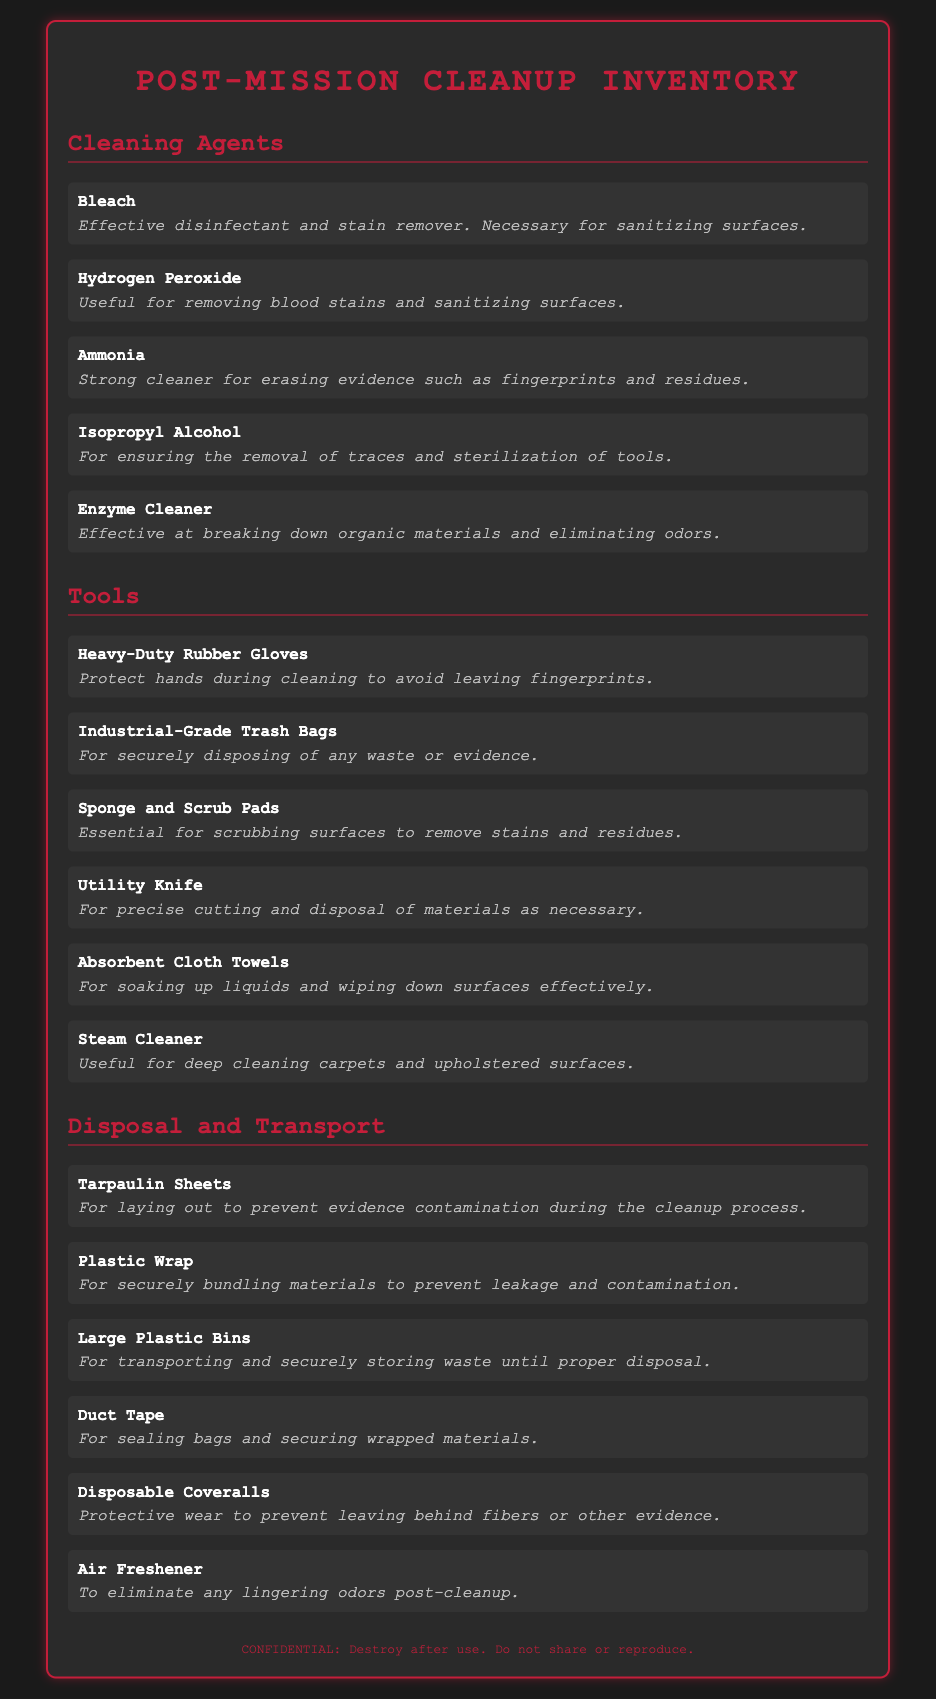What is the first cleaning agent listed? The first cleaning agent listed in the document is mentioned in the "Cleaning Agents" section.
Answer: Bleach How many cleaning agents are listed in total? The number of cleaning agents can be counted in the document under the "Cleaning Agents" category.
Answer: 5 What is the purpose of Hydrogen Peroxide? The purpose of Hydrogen Peroxide is described in the document and indicates its primary use.
Answer: Removing blood stains and sanitizing surfaces What type of gloves are mentioned for cleanup? The type of gloves used during cleanup is specified in the "Tools" section of the document.
Answer: Heavy-Duty Rubber Gloves Which tool is used for deep cleaning carpets? The tool designed for deep cleaning carpets is identified in the "Tools" section.
Answer: Steam Cleaner What is the function of Industrial-Grade Trash Bags? The function of Industrial-Grade Trash Bags is detailed in the "Tools" section.
Answer: For securely disposing of any waste or evidence How many items are in the "Disposal and Transport" category? The number of items in the "Disposal and Transport" category can be determined by counting the entries listed.
Answer: 6 What is recommended to prevent evidence contamination? The document states what should be laid out to prevent contamination during cleanup.
Answer: Tarpaulin Sheets What should be used for sealing bags? The item specified in the document for sealing bags is found in the "Disposal and Transport" section.
Answer: Duct Tape 